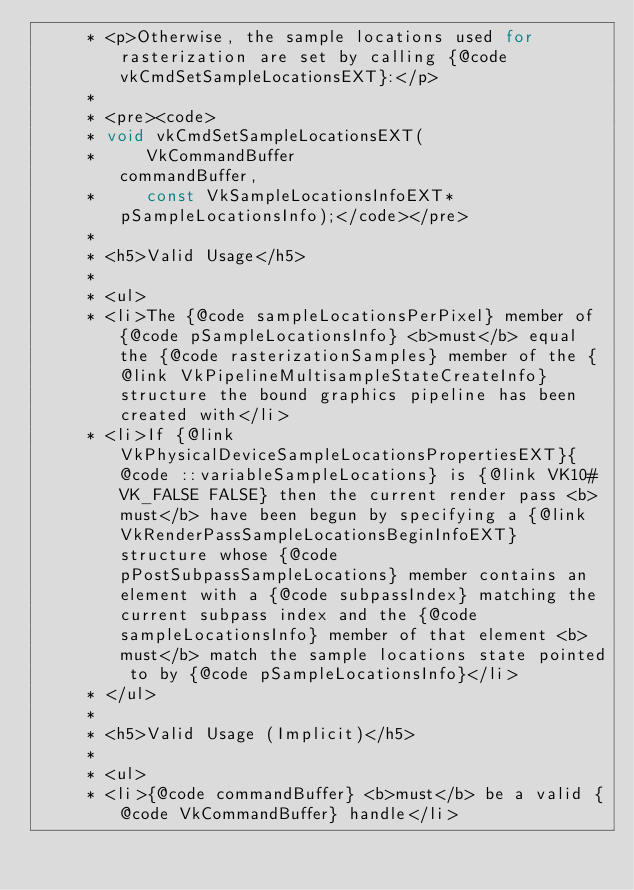<code> <loc_0><loc_0><loc_500><loc_500><_Java_>     * <p>Otherwise, the sample locations used for rasterization are set by calling {@code vkCmdSetSampleLocationsEXT}:</p>
     * 
     * <pre><code>
     * void vkCmdSetSampleLocationsEXT(
     *     VkCommandBuffer                             commandBuffer,
     *     const VkSampleLocationsInfoEXT*             pSampleLocationsInfo);</code></pre>
     * 
     * <h5>Valid Usage</h5>
     * 
     * <ul>
     * <li>The {@code sampleLocationsPerPixel} member of {@code pSampleLocationsInfo} <b>must</b> equal the {@code rasterizationSamples} member of the {@link VkPipelineMultisampleStateCreateInfo} structure the bound graphics pipeline has been created with</li>
     * <li>If {@link VkPhysicalDeviceSampleLocationsPropertiesEXT}{@code ::variableSampleLocations} is {@link VK10#VK_FALSE FALSE} then the current render pass <b>must</b> have been begun by specifying a {@link VkRenderPassSampleLocationsBeginInfoEXT} structure whose {@code pPostSubpassSampleLocations} member contains an element with a {@code subpassIndex} matching the current subpass index and the {@code sampleLocationsInfo} member of that element <b>must</b> match the sample locations state pointed to by {@code pSampleLocationsInfo}</li>
     * </ul>
     * 
     * <h5>Valid Usage (Implicit)</h5>
     * 
     * <ul>
     * <li>{@code commandBuffer} <b>must</b> be a valid {@code VkCommandBuffer} handle</li></code> 